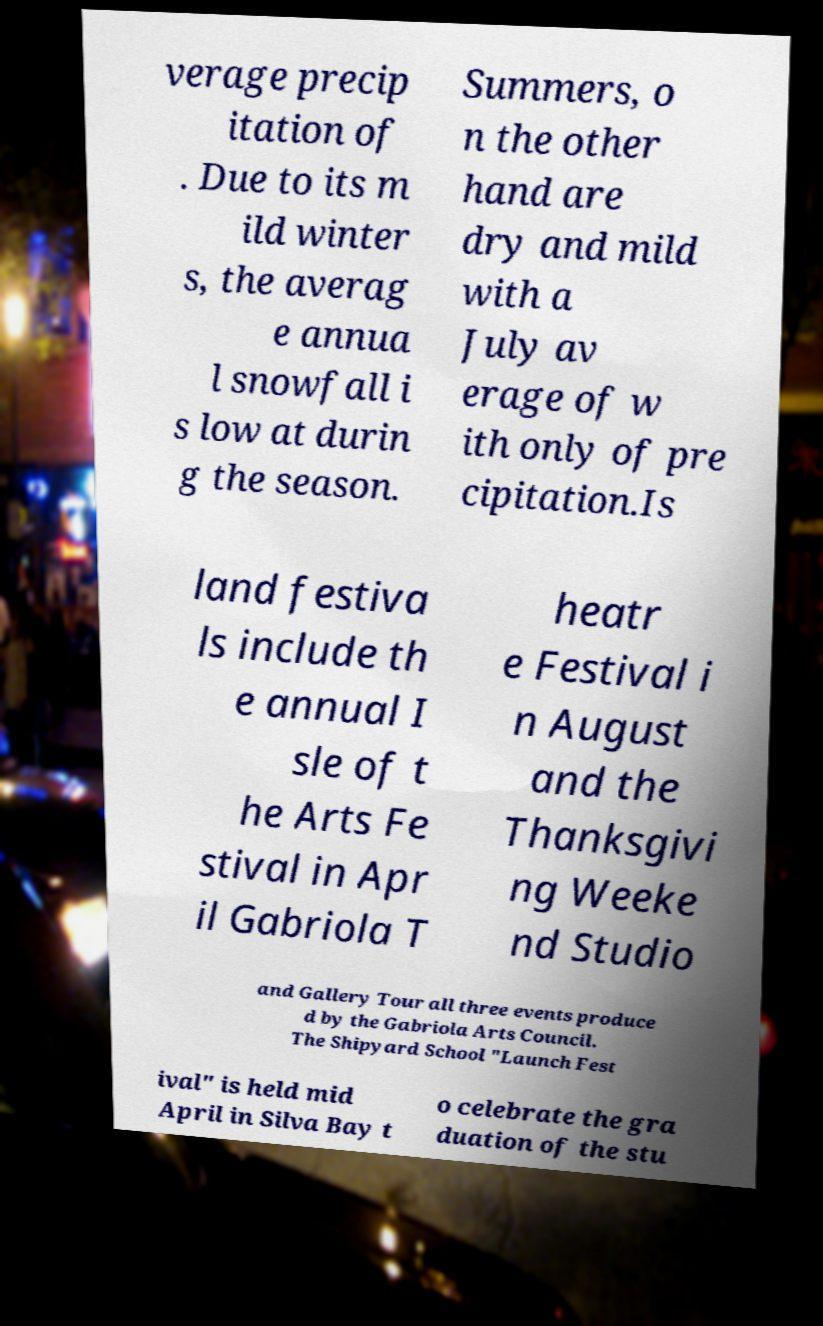Can you accurately transcribe the text from the provided image for me? verage precip itation of . Due to its m ild winter s, the averag e annua l snowfall i s low at durin g the season. Summers, o n the other hand are dry and mild with a July av erage of w ith only of pre cipitation.Is land festiva ls include th e annual I sle of t he Arts Fe stival in Apr il Gabriola T heatr e Festival i n August and the Thanksgivi ng Weeke nd Studio and Gallery Tour all three events produce d by the Gabriola Arts Council. The Shipyard School "Launch Fest ival" is held mid April in Silva Bay t o celebrate the gra duation of the stu 